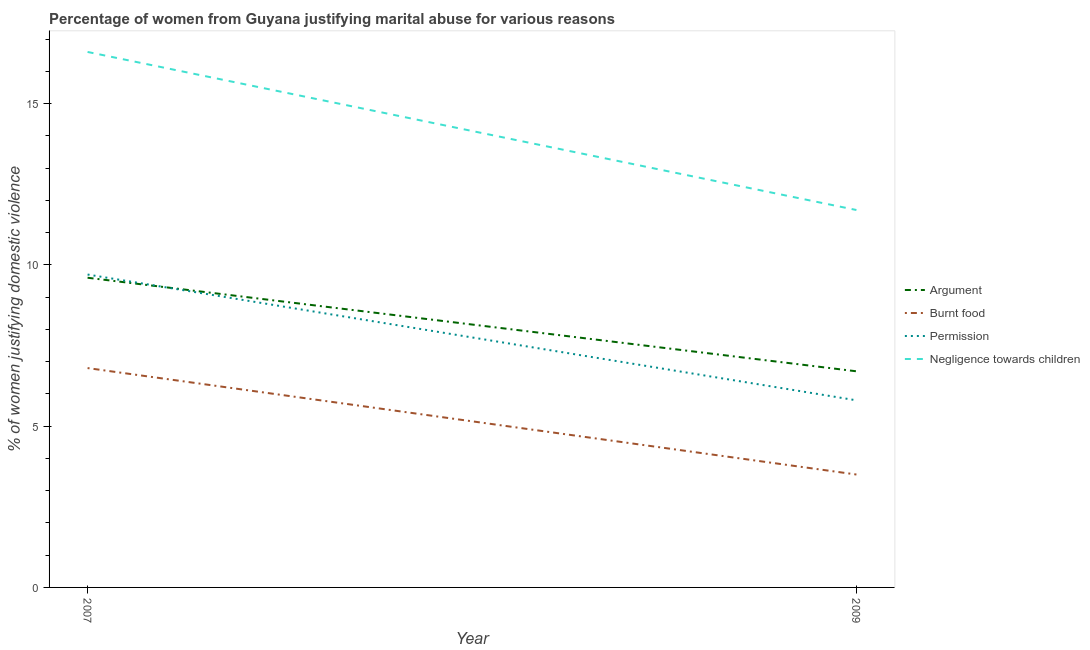How many different coloured lines are there?
Provide a short and direct response. 4. Is the number of lines equal to the number of legend labels?
Provide a short and direct response. Yes. Across all years, what is the maximum percentage of women justifying abuse for burning food?
Offer a very short reply. 6.8. In which year was the percentage of women justifying abuse for showing negligence towards children maximum?
Keep it short and to the point. 2007. In which year was the percentage of women justifying abuse in the case of an argument minimum?
Ensure brevity in your answer.  2009. What is the difference between the percentage of women justifying abuse in the case of an argument in 2007 and that in 2009?
Offer a terse response. 2.9. What is the average percentage of women justifying abuse in the case of an argument per year?
Your response must be concise. 8.15. What is the ratio of the percentage of women justifying abuse for burning food in 2007 to that in 2009?
Make the answer very short. 1.94. Is the percentage of women justifying abuse in the case of an argument in 2007 less than that in 2009?
Ensure brevity in your answer.  No. In how many years, is the percentage of women justifying abuse for showing negligence towards children greater than the average percentage of women justifying abuse for showing negligence towards children taken over all years?
Your response must be concise. 1. Does the percentage of women justifying abuse in the case of an argument monotonically increase over the years?
Provide a succinct answer. No. Is the percentage of women justifying abuse in the case of an argument strictly greater than the percentage of women justifying abuse for burning food over the years?
Your response must be concise. Yes. Is the percentage of women justifying abuse for showing negligence towards children strictly less than the percentage of women justifying abuse in the case of an argument over the years?
Provide a short and direct response. No. How many years are there in the graph?
Give a very brief answer. 2. What is the difference between two consecutive major ticks on the Y-axis?
Your answer should be compact. 5. How many legend labels are there?
Offer a very short reply. 4. How are the legend labels stacked?
Make the answer very short. Vertical. What is the title of the graph?
Offer a terse response. Percentage of women from Guyana justifying marital abuse for various reasons. What is the label or title of the Y-axis?
Provide a succinct answer. % of women justifying domestic violence. What is the % of women justifying domestic violence of Argument in 2007?
Your answer should be very brief. 9.6. What is the % of women justifying domestic violence of Argument in 2009?
Your answer should be very brief. 6.7. What is the % of women justifying domestic violence in Permission in 2009?
Keep it short and to the point. 5.8. What is the % of women justifying domestic violence in Negligence towards children in 2009?
Make the answer very short. 11.7. Across all years, what is the maximum % of women justifying domestic violence in Argument?
Give a very brief answer. 9.6. Across all years, what is the maximum % of women justifying domestic violence of Permission?
Offer a very short reply. 9.7. Across all years, what is the maximum % of women justifying domestic violence of Negligence towards children?
Your response must be concise. 16.6. Across all years, what is the minimum % of women justifying domestic violence in Argument?
Make the answer very short. 6.7. Across all years, what is the minimum % of women justifying domestic violence in Permission?
Your response must be concise. 5.8. What is the total % of women justifying domestic violence of Argument in the graph?
Give a very brief answer. 16.3. What is the total % of women justifying domestic violence of Negligence towards children in the graph?
Your answer should be very brief. 28.3. What is the difference between the % of women justifying domestic violence in Negligence towards children in 2007 and that in 2009?
Provide a succinct answer. 4.9. What is the difference between the % of women justifying domestic violence in Argument in 2007 and the % of women justifying domestic violence in Burnt food in 2009?
Make the answer very short. 6.1. What is the difference between the % of women justifying domestic violence in Burnt food in 2007 and the % of women justifying domestic violence in Negligence towards children in 2009?
Offer a terse response. -4.9. What is the average % of women justifying domestic violence in Argument per year?
Ensure brevity in your answer.  8.15. What is the average % of women justifying domestic violence of Burnt food per year?
Keep it short and to the point. 5.15. What is the average % of women justifying domestic violence of Permission per year?
Keep it short and to the point. 7.75. What is the average % of women justifying domestic violence in Negligence towards children per year?
Your response must be concise. 14.15. In the year 2007, what is the difference between the % of women justifying domestic violence in Argument and % of women justifying domestic violence in Negligence towards children?
Provide a succinct answer. -7. In the year 2009, what is the difference between the % of women justifying domestic violence of Argument and % of women justifying domestic violence of Permission?
Give a very brief answer. 0.9. In the year 2009, what is the difference between the % of women justifying domestic violence of Argument and % of women justifying domestic violence of Negligence towards children?
Your answer should be very brief. -5. In the year 2009, what is the difference between the % of women justifying domestic violence of Permission and % of women justifying domestic violence of Negligence towards children?
Provide a short and direct response. -5.9. What is the ratio of the % of women justifying domestic violence in Argument in 2007 to that in 2009?
Your response must be concise. 1.43. What is the ratio of the % of women justifying domestic violence of Burnt food in 2007 to that in 2009?
Ensure brevity in your answer.  1.94. What is the ratio of the % of women justifying domestic violence of Permission in 2007 to that in 2009?
Your answer should be very brief. 1.67. What is the ratio of the % of women justifying domestic violence of Negligence towards children in 2007 to that in 2009?
Provide a succinct answer. 1.42. What is the difference between the highest and the second highest % of women justifying domestic violence in Burnt food?
Keep it short and to the point. 3.3. What is the difference between the highest and the second highest % of women justifying domestic violence of Negligence towards children?
Give a very brief answer. 4.9. What is the difference between the highest and the lowest % of women justifying domestic violence in Permission?
Offer a very short reply. 3.9. What is the difference between the highest and the lowest % of women justifying domestic violence of Negligence towards children?
Give a very brief answer. 4.9. 